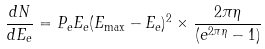<formula> <loc_0><loc_0><loc_500><loc_500>\frac { d N } { d E _ { e } } = P _ { e } E _ { e } ( E _ { \max } - E _ { e } ) ^ { 2 } \times \frac { 2 \pi \eta } { ( e ^ { 2 \pi \eta } - 1 ) }</formula> 